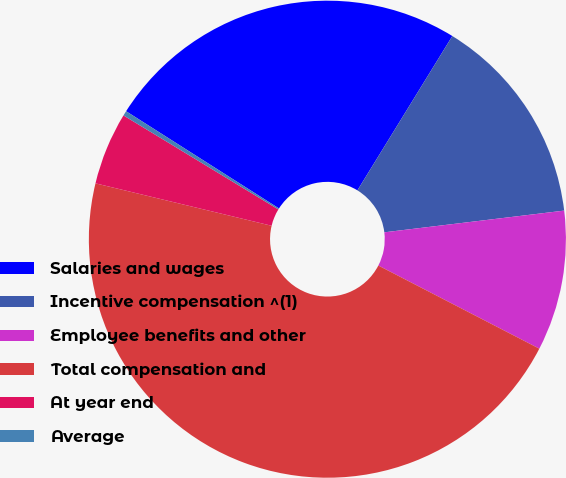<chart> <loc_0><loc_0><loc_500><loc_500><pie_chart><fcel>Salaries and wages<fcel>Incentive compensation ^(1)<fcel>Employee benefits and other<fcel>Total compensation and<fcel>At year end<fcel>Average<nl><fcel>24.76%<fcel>14.31%<fcel>9.5%<fcel>46.17%<fcel>4.92%<fcel>0.33%<nl></chart> 